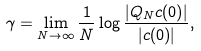Convert formula to latex. <formula><loc_0><loc_0><loc_500><loc_500>\gamma = \lim _ { N \to \infty } \frac { 1 } { N } \log \frac { | Q _ { N } c ( 0 ) | } { | c ( 0 ) | } ,</formula> 